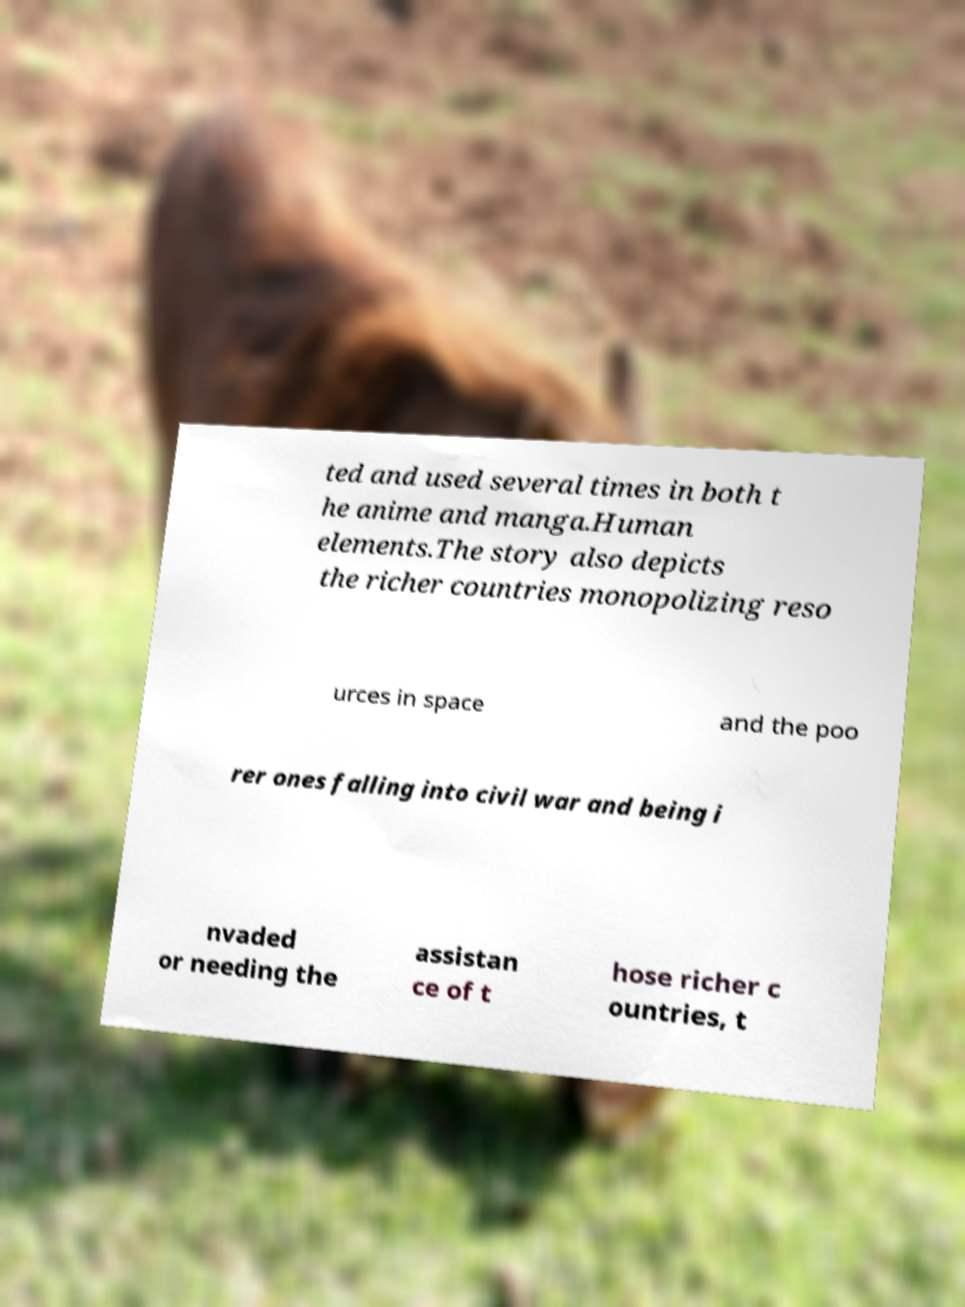For documentation purposes, I need the text within this image transcribed. Could you provide that? ted and used several times in both t he anime and manga.Human elements.The story also depicts the richer countries monopolizing reso urces in space and the poo rer ones falling into civil war and being i nvaded or needing the assistan ce of t hose richer c ountries, t 